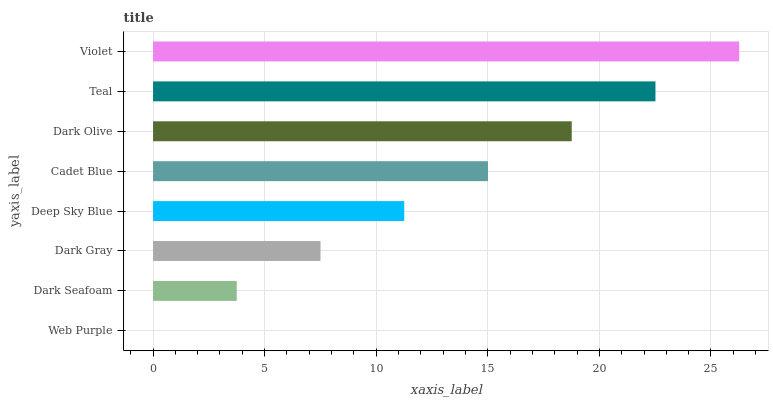Is Web Purple the minimum?
Answer yes or no. Yes. Is Violet the maximum?
Answer yes or no. Yes. Is Dark Seafoam the minimum?
Answer yes or no. No. Is Dark Seafoam the maximum?
Answer yes or no. No. Is Dark Seafoam greater than Web Purple?
Answer yes or no. Yes. Is Web Purple less than Dark Seafoam?
Answer yes or no. Yes. Is Web Purple greater than Dark Seafoam?
Answer yes or no. No. Is Dark Seafoam less than Web Purple?
Answer yes or no. No. Is Cadet Blue the high median?
Answer yes or no. Yes. Is Deep Sky Blue the low median?
Answer yes or no. Yes. Is Violet the high median?
Answer yes or no. No. Is Dark Gray the low median?
Answer yes or no. No. 